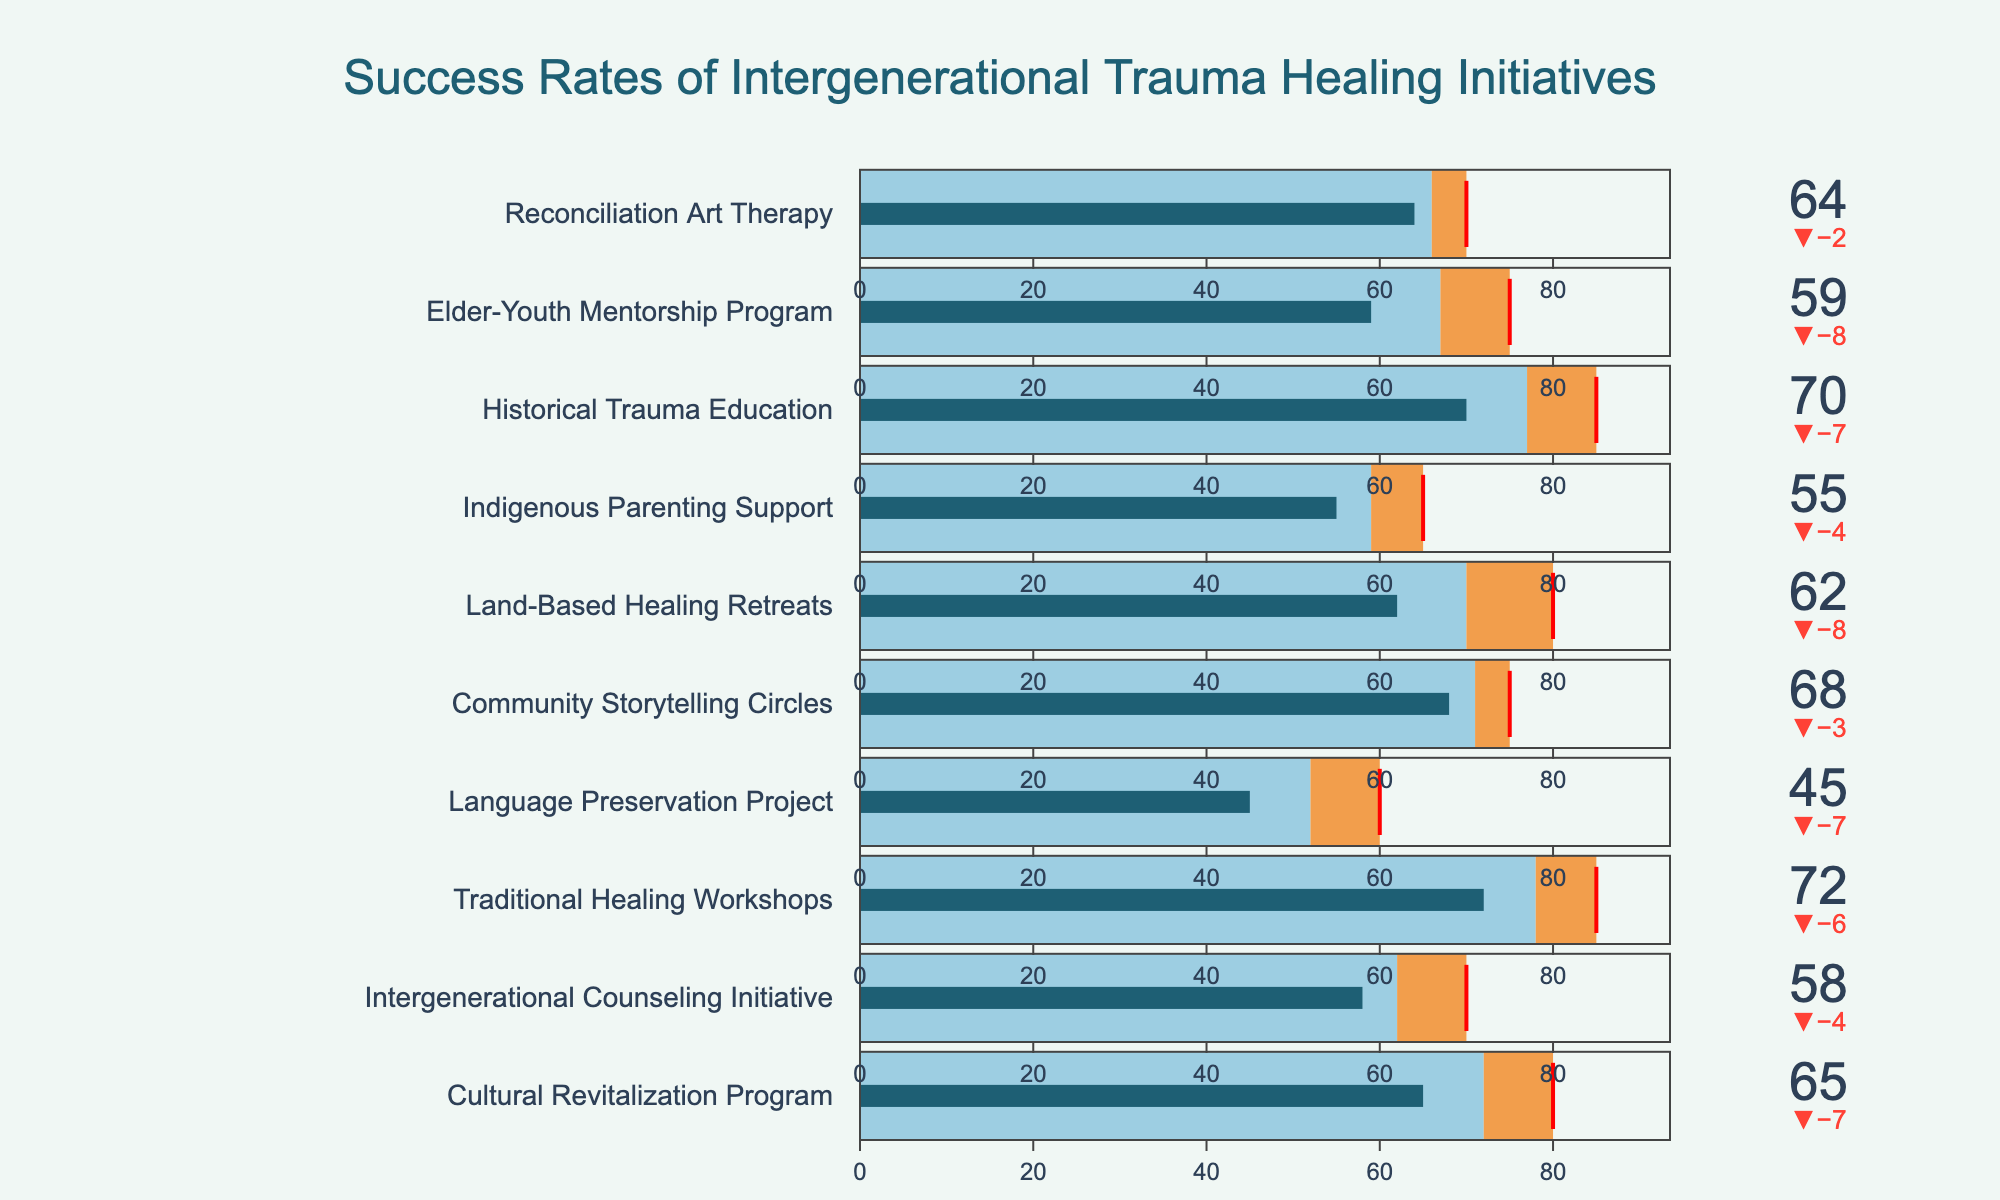What's the title of this bullet chart? Look at the top of the figure, where the title is usually placed.
Answer: "Success Rates of Intergenerational Trauma Healing Initiatives" How many programs have actual success rates above 60? Count the number of programs where the actual rate is greater than 60.
Answer: 7 Which program has the highest actual success rate? Compare the actual success rates of all programs and identify the highest one.
Answer: Traditional Healing Workshops Which program has the largest gap between its actual success rate and its target? Calculate the difference between actual and target success rates for each program and identify the largest gap.
Answer: Land-Based Healing Retreats What's the average actual success rate of all programs? Sum all actual success rates and divide by the number of programs (65 + 58 + 72 + 45 + 68 + 62 + 55 + 70 + 59 + 64 = 618, 618/10).
Answer: 61.8 How does the Community Storytelling Circles program's actual success rate compare to its comparison value? Compare the actual success rate (68) with the comparison value (71).
Answer: It is lower Are there any programs where the actual success rate meets or exceeds the target? Check if any actual success rate is equal to or greater than the target for any program.
Answer: No What's the difference between the target and the actual success rate for the Elder-Youth Mentorship Program? Subtract the actual success rate (59) from the target success rate (75).
Answer: 16 Which two programs have the closest actual success rates? Compare the actual success rates of all programs and find the pair with the smallest difference.
Answer: Elder-Youth Mentorship Program and Intergenerational Counseling Initiative What color represents the segment between the comparison value and the target in the bullet charts? Identify the color used for steps between comparison value and target.
Answer: Orange 